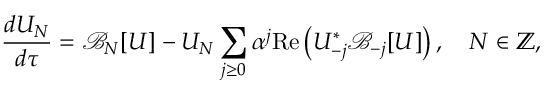Convert formula to latex. <formula><loc_0><loc_0><loc_500><loc_500>\frac { d U _ { N } } { d \tau } = \mathcal { B } _ { N } [ U ] - U _ { N } \sum _ { j \geq 0 } \alpha ^ { j } R e \left ( U _ { - j } ^ { * } \mathcal { B } _ { - j } [ U ] \right ) , \quad N \in \mathbb { Z } ,</formula> 